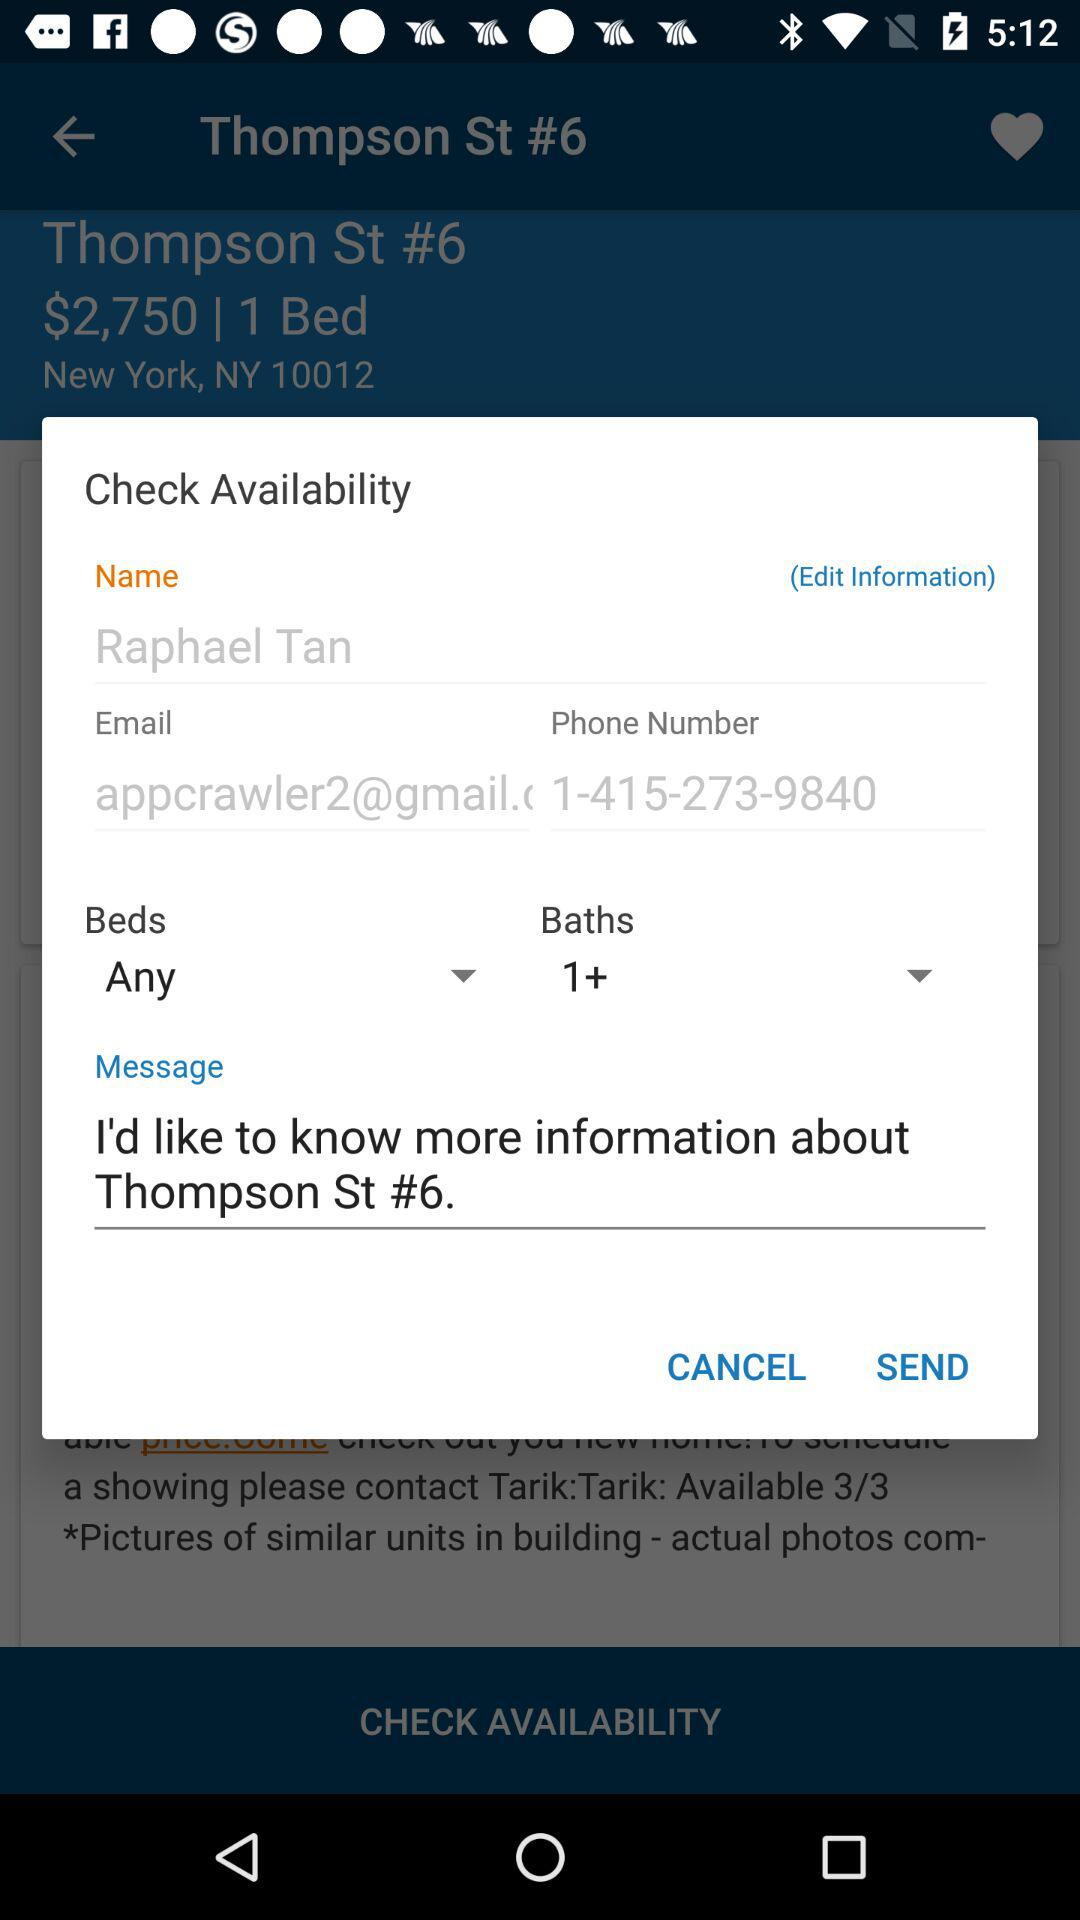How many beds are available?
Answer the question using a single word or phrase. Any 